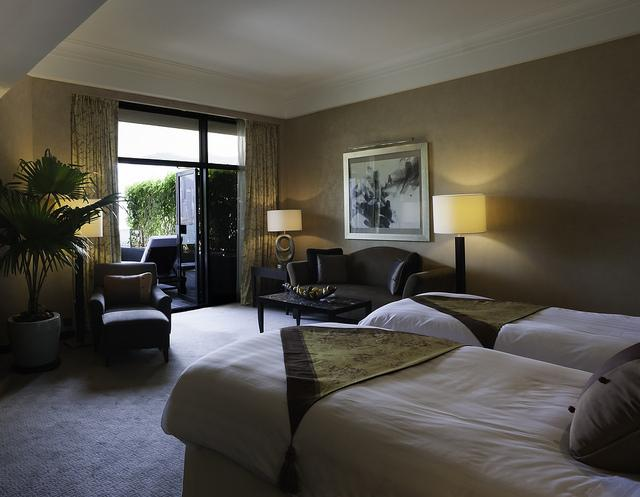What is the tray on the coffee table filled with most likely as decoration? Please explain your reasoning. fruit. There is fruit in the room. 